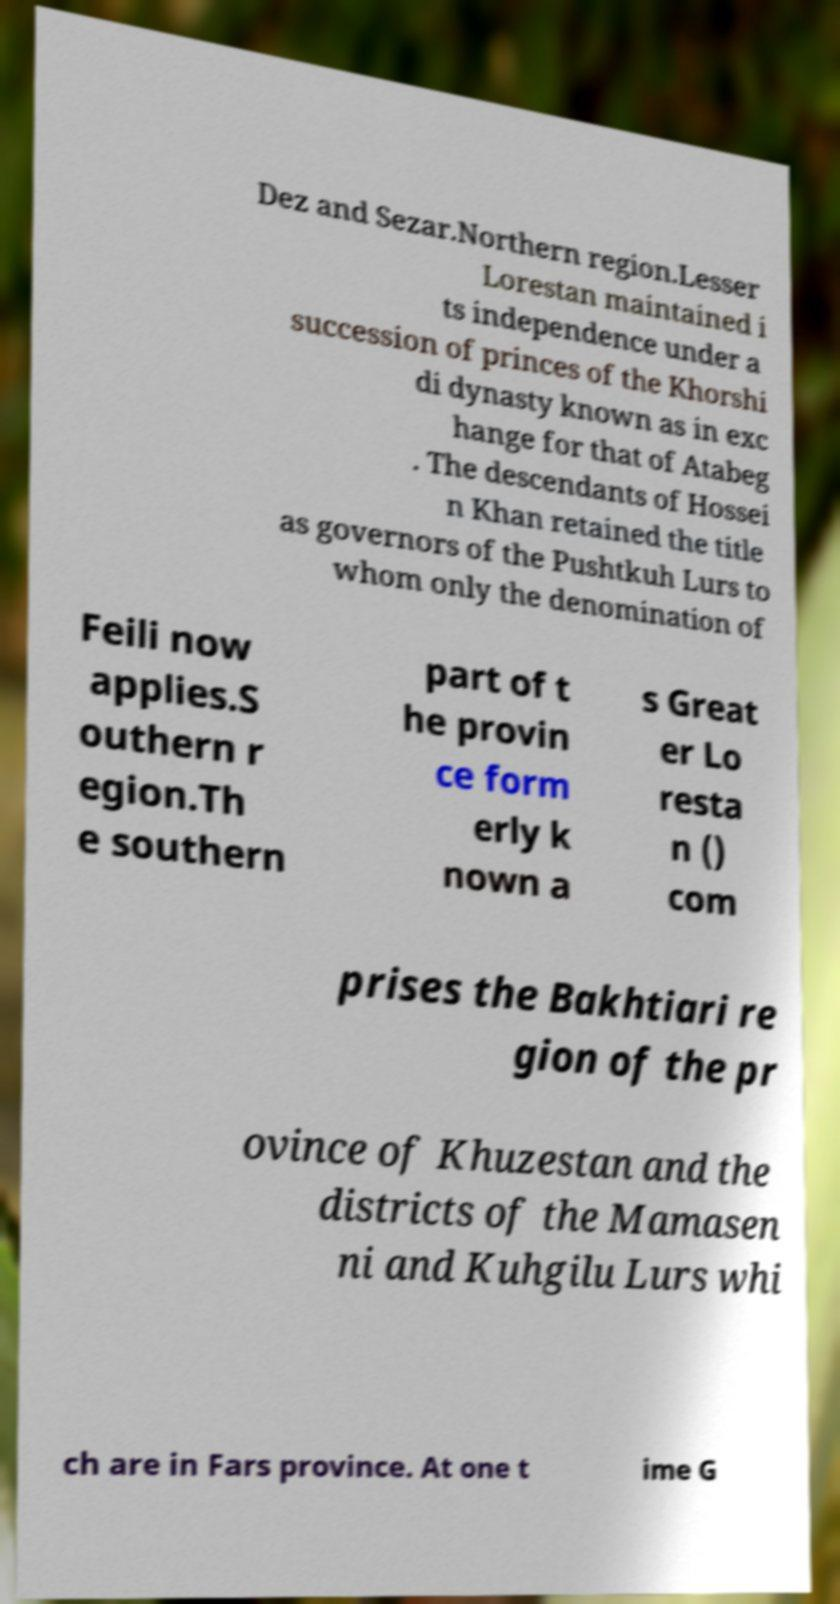For documentation purposes, I need the text within this image transcribed. Could you provide that? Dez and Sezar.Northern region.Lesser Lorestan maintained i ts independence under a succession of princes of the Khorshi di dynasty known as in exc hange for that of Atabeg . The descendants of Hossei n Khan retained the title as governors of the Pushtkuh Lurs to whom only the denomination of Feili now applies.S outhern r egion.Th e southern part of t he provin ce form erly k nown a s Great er Lo resta n () com prises the Bakhtiari re gion of the pr ovince of Khuzestan and the districts of the Mamasen ni and Kuhgilu Lurs whi ch are in Fars province. At one t ime G 